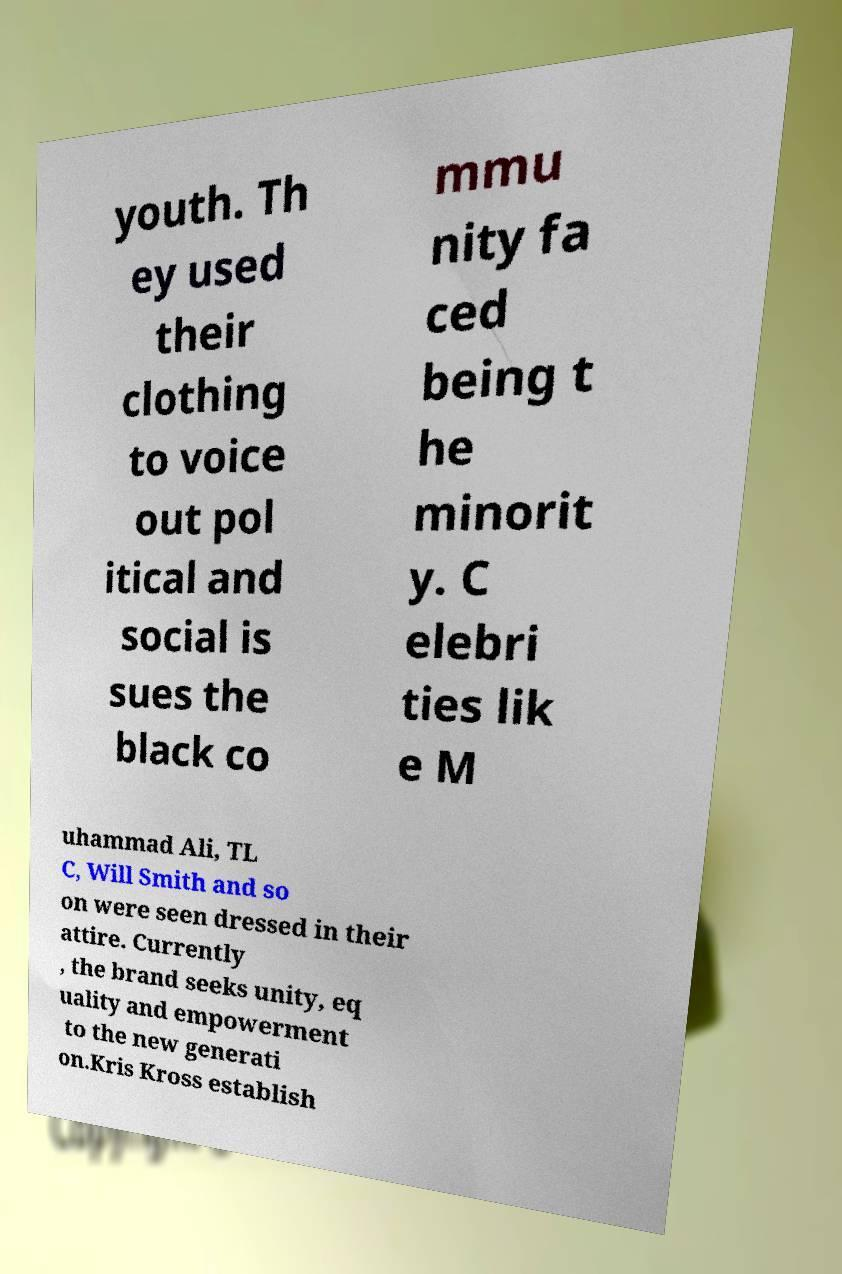What messages or text are displayed in this image? I need them in a readable, typed format. youth. Th ey used their clothing to voice out pol itical and social is sues the black co mmu nity fa ced being t he minorit y. C elebri ties lik e M uhammad Ali, TL C, Will Smith and so on were seen dressed in their attire. Currently , the brand seeks unity, eq uality and empowerment to the new generati on.Kris Kross establish 